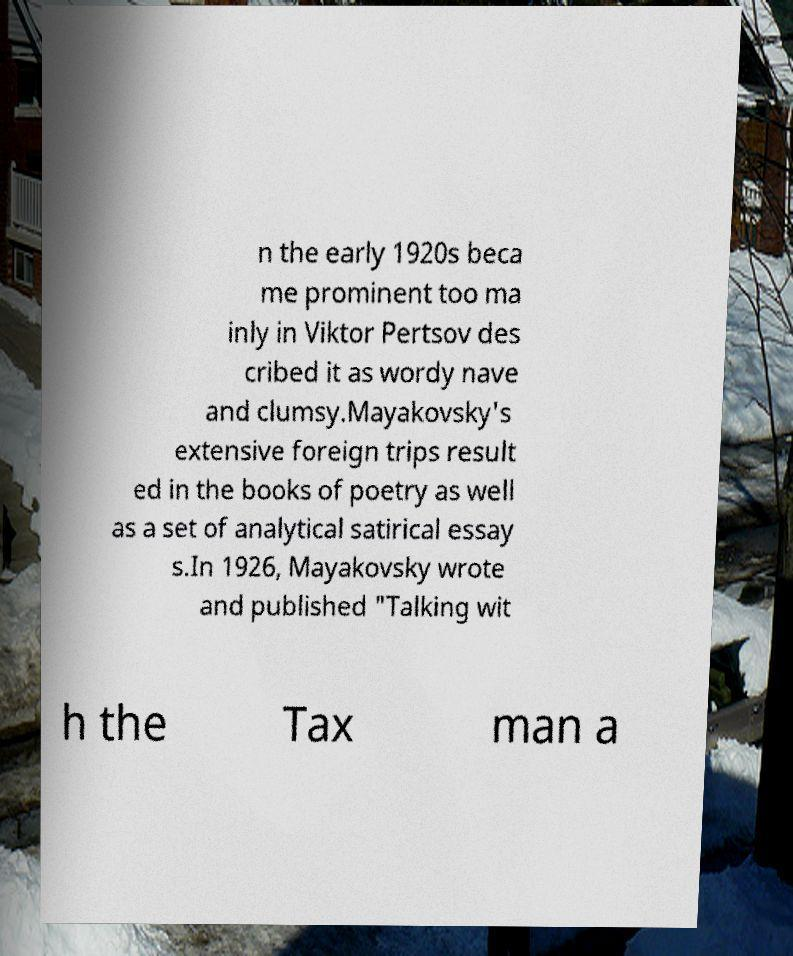Could you assist in decoding the text presented in this image and type it out clearly? n the early 1920s beca me prominent too ma inly in Viktor Pertsov des cribed it as wordy nave and clumsy.Mayakovsky's extensive foreign trips result ed in the books of poetry as well as a set of analytical satirical essay s.In 1926, Mayakovsky wrote and published "Talking wit h the Tax man a 